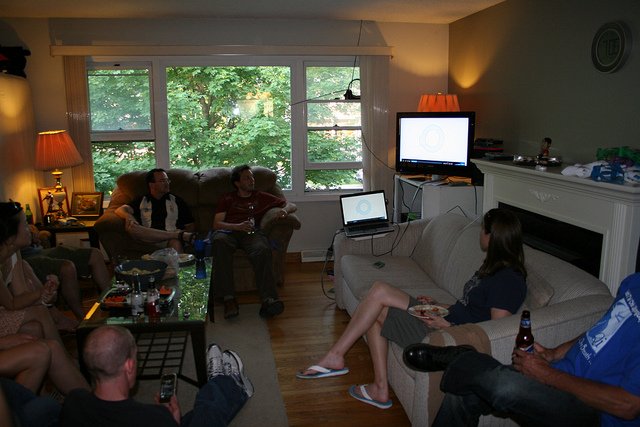<image>What is the man playing? I don't know what the man is playing. It could be a video game or a game on his phone. What is the man playing? I don't know what the man is playing. It can be a video game, phone game, or nothing. 